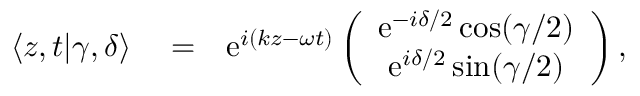<formula> <loc_0><loc_0><loc_500><loc_500>\begin{array} { r l r } { \langle z , t | \gamma , \delta \rangle } & = } & { e ^ { i ( k z - \omega t ) } \left ( \begin{array} { c } { e ^ { - i \delta / 2 } \cos ( \gamma / 2 ) } \\ { e ^ { i \delta / 2 } \sin ( \gamma / 2 ) } \end{array} \right ) , } \end{array}</formula> 